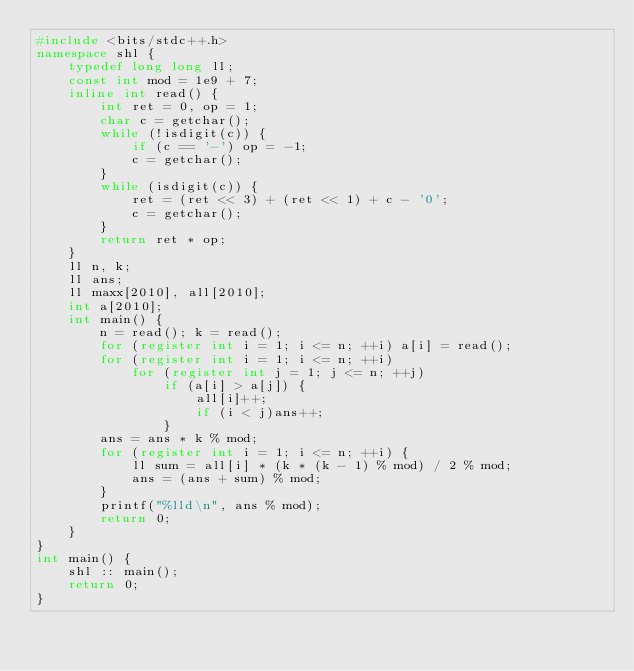<code> <loc_0><loc_0><loc_500><loc_500><_C++_>#include <bits/stdc++.h>
namespace shl {
	typedef long long ll;
	const int mod = 1e9 + 7;
	inline int read() {
		int ret = 0, op = 1;
		char c = getchar();
		while (!isdigit(c)) {
			if (c == '-') op = -1; 
			c = getchar();
		}
		while (isdigit(c)) {
			ret = (ret << 3) + (ret << 1) + c - '0';
			c = getchar();
		}
		return ret * op;
	}
	ll n, k;
	ll ans;
	ll maxx[2010], all[2010];
	int a[2010];
	int main() {
		n = read(); k = read();
		for (register int i = 1; i <= n; ++i) a[i] = read();
		for (register int i = 1; i <= n; ++i) 
			for (register int j = 1; j <= n; ++j)
				if (a[i] > a[j]) {
					all[i]++;
					if (i < j)ans++;
				}
		ans = ans * k % mod;
		for (register int i = 1; i <= n; ++i) {
			ll sum = all[i] * (k * (k - 1) % mod) / 2 % mod;
			ans = (ans + sum) % mod;
		}
		printf("%lld\n", ans % mod);
		return 0;
	}
}
int main() {
	shl :: main();
	return 0;
}</code> 